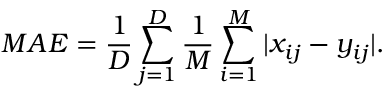<formula> <loc_0><loc_0><loc_500><loc_500>M A E = \frac { 1 } { D } \sum _ { j = 1 } ^ { D } \frac { 1 } { M } \sum _ { i = 1 } ^ { M } | x _ { i j } - y _ { i j } | .</formula> 